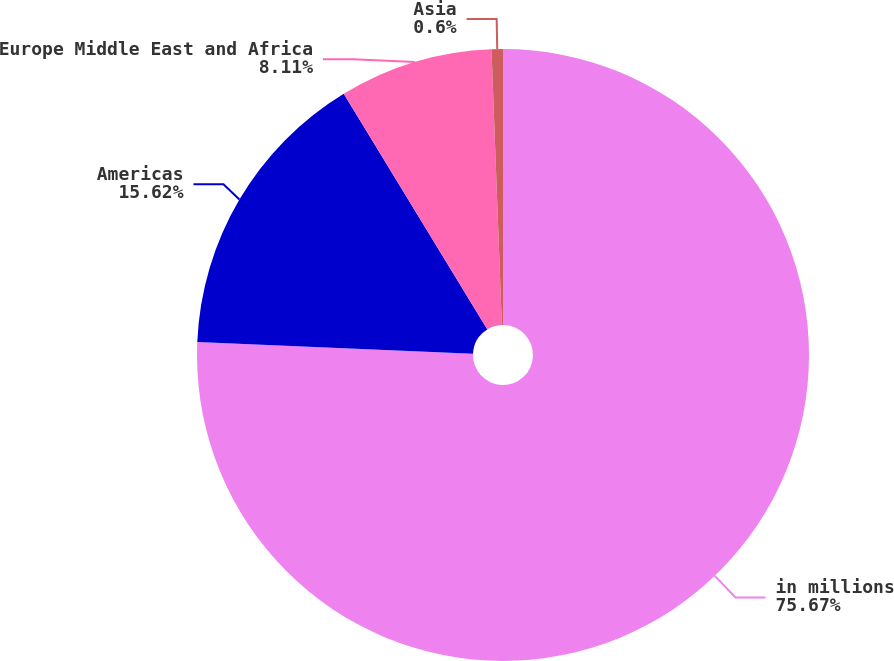Convert chart. <chart><loc_0><loc_0><loc_500><loc_500><pie_chart><fcel>in millions<fcel>Americas<fcel>Europe Middle East and Africa<fcel>Asia<nl><fcel>75.67%<fcel>15.62%<fcel>8.11%<fcel>0.6%<nl></chart> 